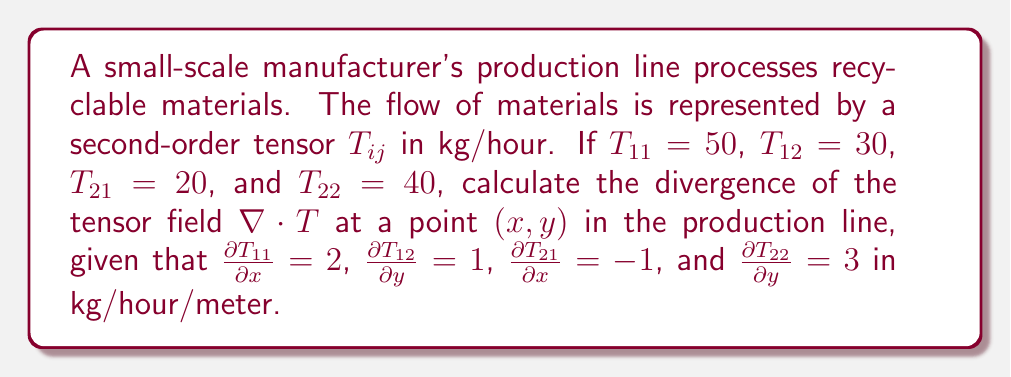Could you help me with this problem? To solve this problem, we need to follow these steps:

1) The divergence of a second-order tensor $T_{ij}$ in 2D is given by:

   $$\nabla \cdot T = \frac{\partial T_{11}}{\partial x} + \frac{\partial T_{12}}{\partial y} + \frac{\partial T_{21}}{\partial x} + \frac{\partial T_{22}}{\partial y}$$

2) We are given the following values:
   $\frac{\partial T_{11}}{\partial x} = 2$
   $\frac{\partial T_{12}}{\partial y} = 1$
   $\frac{\partial T_{21}}{\partial x} = -1$
   $\frac{\partial T_{22}}{\partial y} = 3$

3) Now, let's substitute these values into the divergence formula:

   $$\nabla \cdot T = 2 + 1 + (-1) + 3$$

4) Simplify:

   $$\nabla \cdot T = 5$$

5) The units of the divergence will be kg/hour/meter, as each term in the sum has these units.

Therefore, the divergence of the tensor field at the given point is 5 kg/hour/meter.
Answer: 5 kg/hour/meter 